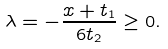<formula> <loc_0><loc_0><loc_500><loc_500>\lambda = - \frac { x + t _ { 1 } } { 6 t _ { 2 } } \geq 0 .</formula> 